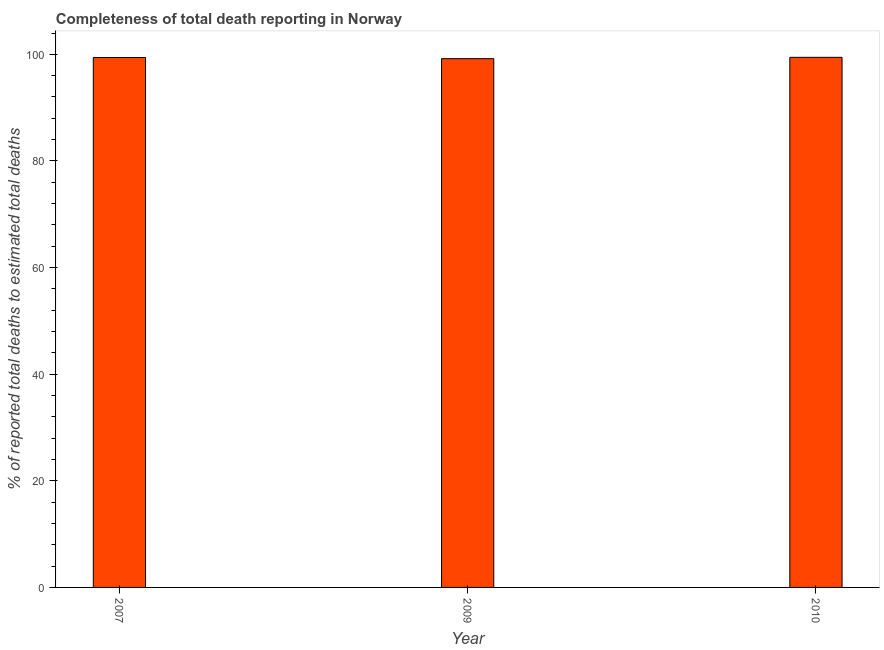Does the graph contain any zero values?
Your response must be concise. No. Does the graph contain grids?
Make the answer very short. No. What is the title of the graph?
Your response must be concise. Completeness of total death reporting in Norway. What is the label or title of the X-axis?
Give a very brief answer. Year. What is the label or title of the Y-axis?
Offer a very short reply. % of reported total deaths to estimated total deaths. What is the completeness of total death reports in 2007?
Offer a very short reply. 99.41. Across all years, what is the maximum completeness of total death reports?
Your answer should be very brief. 99.44. Across all years, what is the minimum completeness of total death reports?
Ensure brevity in your answer.  99.19. In which year was the completeness of total death reports minimum?
Make the answer very short. 2009. What is the sum of the completeness of total death reports?
Ensure brevity in your answer.  298.04. What is the difference between the completeness of total death reports in 2007 and 2009?
Offer a terse response. 0.22. What is the average completeness of total death reports per year?
Keep it short and to the point. 99.35. What is the median completeness of total death reports?
Offer a very short reply. 99.41. Is the difference between the completeness of total death reports in 2007 and 2009 greater than the difference between any two years?
Your answer should be compact. No. What is the difference between the highest and the second highest completeness of total death reports?
Your answer should be very brief. 0.03. In how many years, is the completeness of total death reports greater than the average completeness of total death reports taken over all years?
Provide a succinct answer. 2. Are the values on the major ticks of Y-axis written in scientific E-notation?
Make the answer very short. No. What is the % of reported total deaths to estimated total deaths of 2007?
Provide a succinct answer. 99.41. What is the % of reported total deaths to estimated total deaths in 2009?
Your answer should be compact. 99.19. What is the % of reported total deaths to estimated total deaths of 2010?
Give a very brief answer. 99.44. What is the difference between the % of reported total deaths to estimated total deaths in 2007 and 2009?
Provide a short and direct response. 0.22. What is the difference between the % of reported total deaths to estimated total deaths in 2007 and 2010?
Provide a succinct answer. -0.03. What is the difference between the % of reported total deaths to estimated total deaths in 2009 and 2010?
Provide a short and direct response. -0.25. What is the ratio of the % of reported total deaths to estimated total deaths in 2007 to that in 2009?
Provide a succinct answer. 1. What is the ratio of the % of reported total deaths to estimated total deaths in 2009 to that in 2010?
Offer a terse response. 1. 